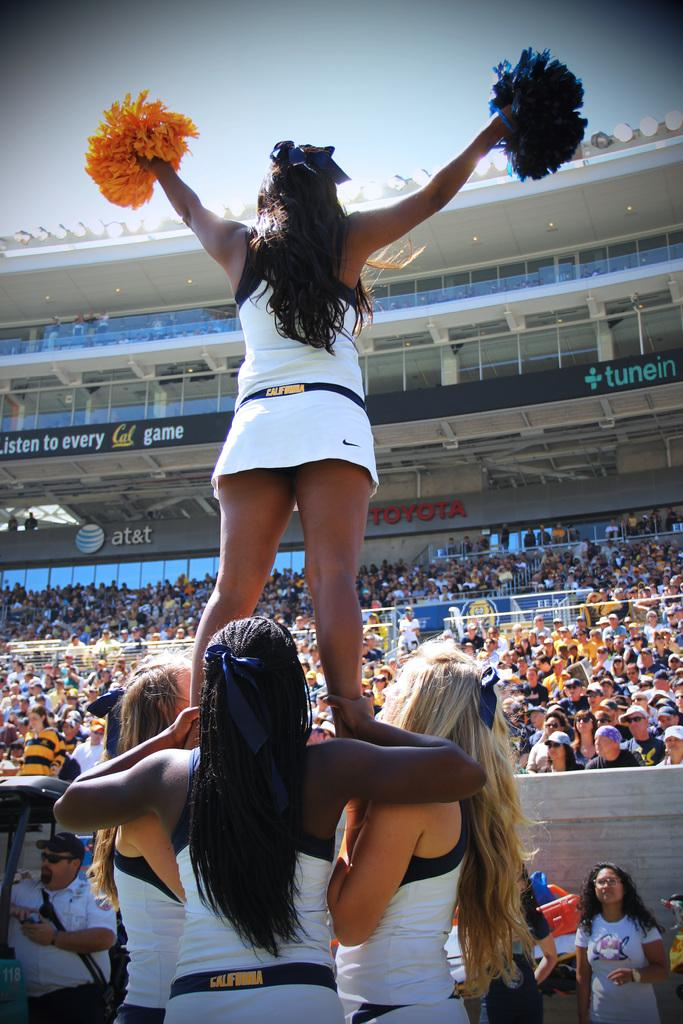<image>
Provide a brief description of the given image. A cheerleader is held up by three others and waves her pom poms at a big crowd seated in a Toyota sponsored stand. 